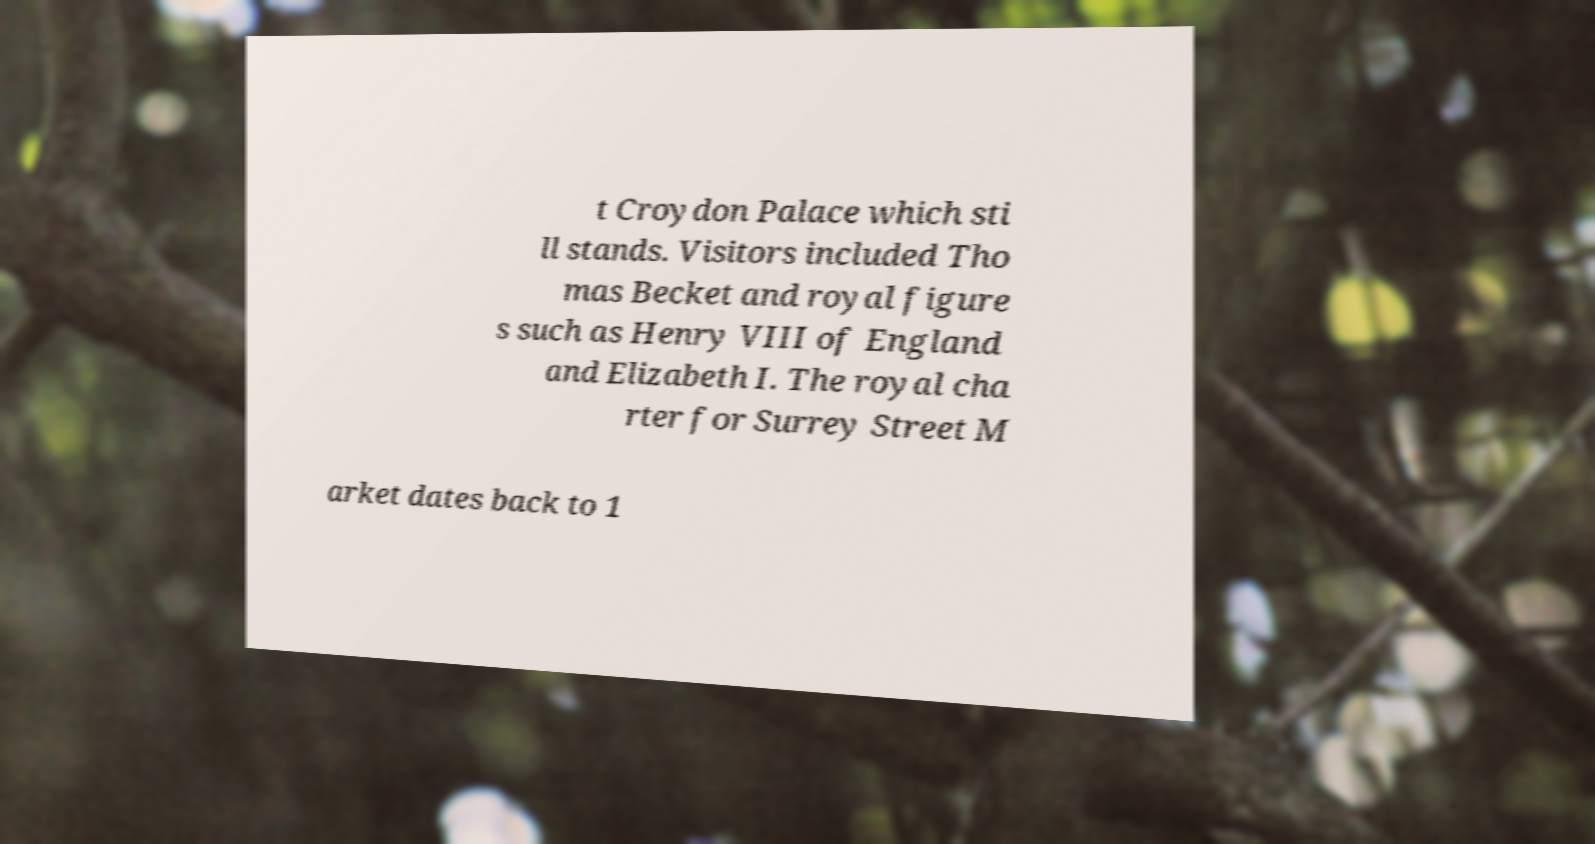Could you extract and type out the text from this image? t Croydon Palace which sti ll stands. Visitors included Tho mas Becket and royal figure s such as Henry VIII of England and Elizabeth I. The royal cha rter for Surrey Street M arket dates back to 1 